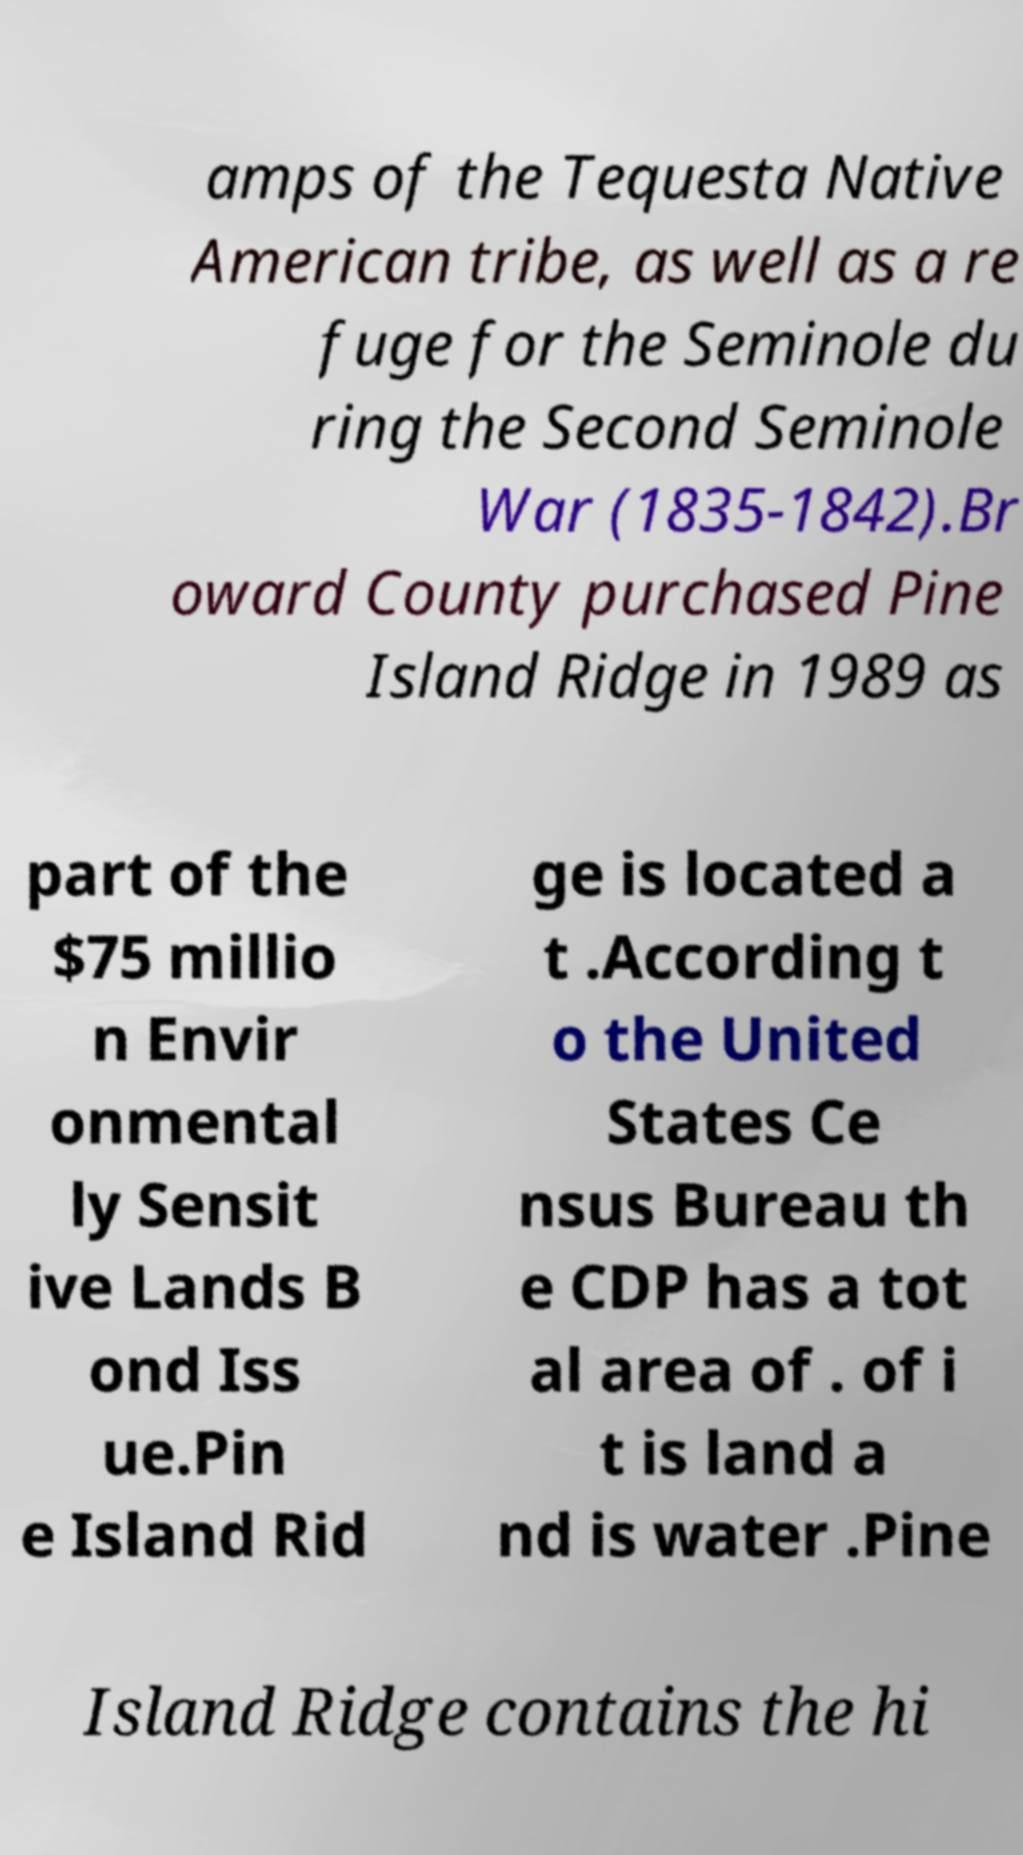Can you read and provide the text displayed in the image?This photo seems to have some interesting text. Can you extract and type it out for me? amps of the Tequesta Native American tribe, as well as a re fuge for the Seminole du ring the Second Seminole War (1835-1842).Br oward County purchased Pine Island Ridge in 1989 as part of the $75 millio n Envir onmental ly Sensit ive Lands B ond Iss ue.Pin e Island Rid ge is located a t .According t o the United States Ce nsus Bureau th e CDP has a tot al area of . of i t is land a nd is water .Pine Island Ridge contains the hi 